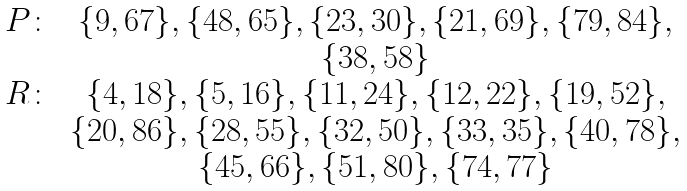<formula> <loc_0><loc_0><loc_500><loc_500>\begin{array} { c c c } P \colon & \{ 9 , 6 7 \} , \{ 4 8 , 6 5 \} , \{ 2 3 , 3 0 \} , \{ 2 1 , 6 9 \} , \{ 7 9 , 8 4 \} , \\ & \{ 3 8 , 5 8 \} \\ R \colon & \{ 4 , 1 8 \} , \{ 5 , 1 6 \} , \{ 1 1 , 2 4 \} , \{ 1 2 , 2 2 \} , \{ 1 9 , 5 2 \} , \\ & \{ 2 0 , 8 6 \} , \{ 2 8 , 5 5 \} , \{ 3 2 , 5 0 \} , \{ 3 3 , 3 5 \} , \{ 4 0 , 7 8 \} , \\ & \{ 4 5 , 6 6 \} , \{ 5 1 , 8 0 \} , \{ 7 4 , 7 7 \} \\ \end{array}</formula> 